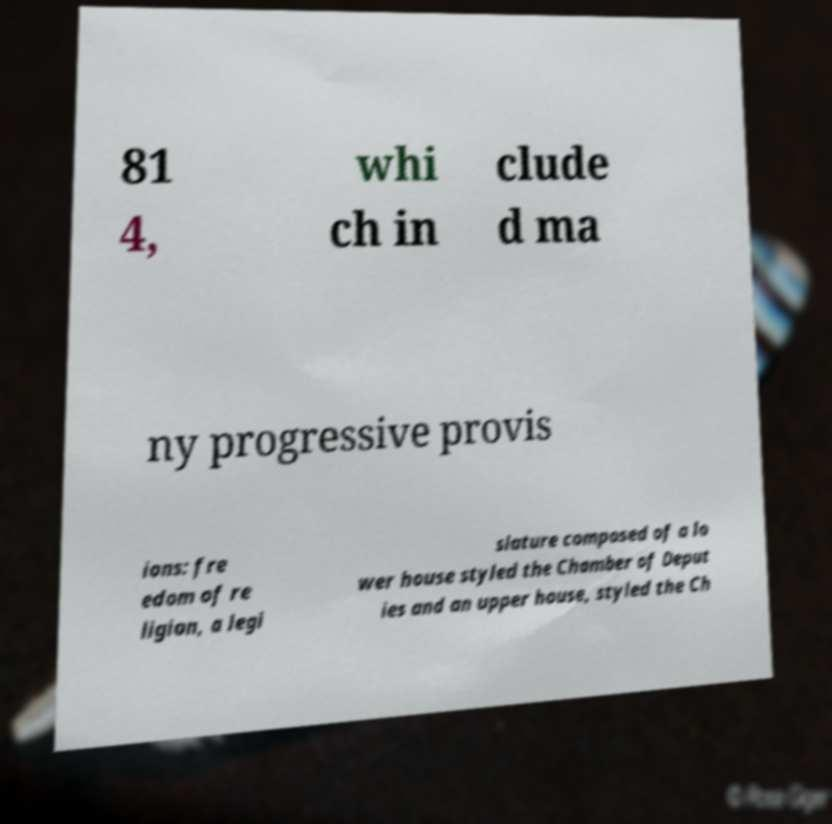There's text embedded in this image that I need extracted. Can you transcribe it verbatim? 81 4, whi ch in clude d ma ny progressive provis ions: fre edom of re ligion, a legi slature composed of a lo wer house styled the Chamber of Deput ies and an upper house, styled the Ch 